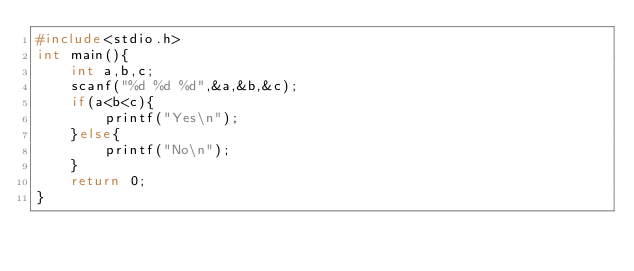Convert code to text. <code><loc_0><loc_0><loc_500><loc_500><_C_>#include<stdio.h>
int main(){
	int a,b,c;
	scanf("%d %d %d",&a,&b,&c);
	if(a<b<c){
		printf("Yes\n");
	}else{
		printf("No\n");
	}
	return 0;
}</code> 